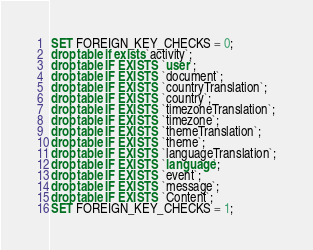<code> <loc_0><loc_0><loc_500><loc_500><_SQL_>SET FOREIGN_KEY_CHECKS = 0;
drop table if exists `activity`;
drop table IF EXISTS `user`;
drop table IF EXISTS `document`;
drop table IF EXISTS `countryTranslation`;
drop table IF EXISTS `country`;
drop table IF EXISTS `timezoneTranslation`;
drop table IF EXISTS `timezone`;
drop table IF EXISTS `themeTranslation`;
drop table IF EXISTS `theme`;
drop table IF EXISTS `languageTranslation`;
drop table IF EXISTS `language`;
drop table IF EXISTS `event`;
drop table IF EXISTS `message`;
drop table IF EXISTS `Content`;
SET FOREIGN_KEY_CHECKS = 1;</code> 